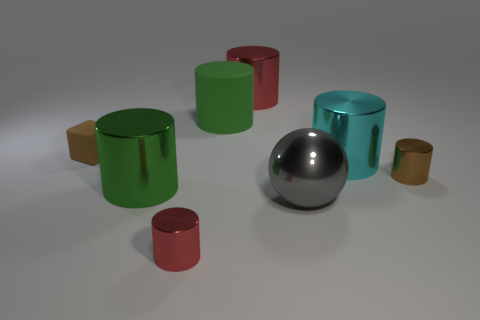Do the cylinder that is in front of the gray shiny thing and the tiny block have the same material?
Offer a very short reply. No. How many small objects are either metal spheres or yellow metal balls?
Give a very brief answer. 0. The green shiny object has what size?
Ensure brevity in your answer.  Large. There is a rubber cube; is it the same size as the red shiny object on the left side of the green matte cylinder?
Ensure brevity in your answer.  Yes. What number of purple objects are either rubber objects or metal cylinders?
Your answer should be very brief. 0. What number of tiny brown cylinders are there?
Provide a succinct answer. 1. There is a red cylinder behind the big cyan thing; what size is it?
Your answer should be compact. Large. Does the green matte cylinder have the same size as the cyan shiny object?
Provide a short and direct response. Yes. What number of things are either tiny purple metal cubes or big objects that are in front of the big green rubber object?
Your answer should be very brief. 3. What material is the brown block?
Your answer should be compact. Rubber. 